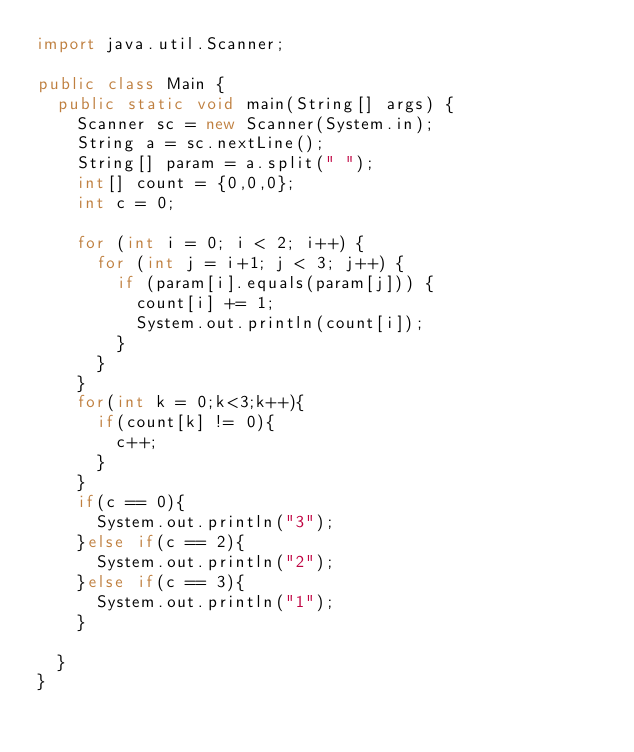<code> <loc_0><loc_0><loc_500><loc_500><_Java_>import java.util.Scanner;

public class Main {
	public static void main(String[] args) {
		Scanner sc = new Scanner(System.in);
		String a = sc.nextLine();
		String[] param = a.split(" ");
		int[] count = {0,0,0};
		int c = 0;

		for (int i = 0; i < 2; i++) {
			for (int j = i+1; j < 3; j++) {
				if (param[i].equals(param[j])) {
					count[i] += 1;
					System.out.println(count[i]);
				}
			}
		}
		for(int k = 0;k<3;k++){
			if(count[k] != 0){
				c++;
			}
		}
		if(c == 0){
			System.out.println("3");
		}else if(c == 2){
			System.out.println("2");
		}else if(c == 3){
			System.out.println("1");
		}

	}
}
</code> 